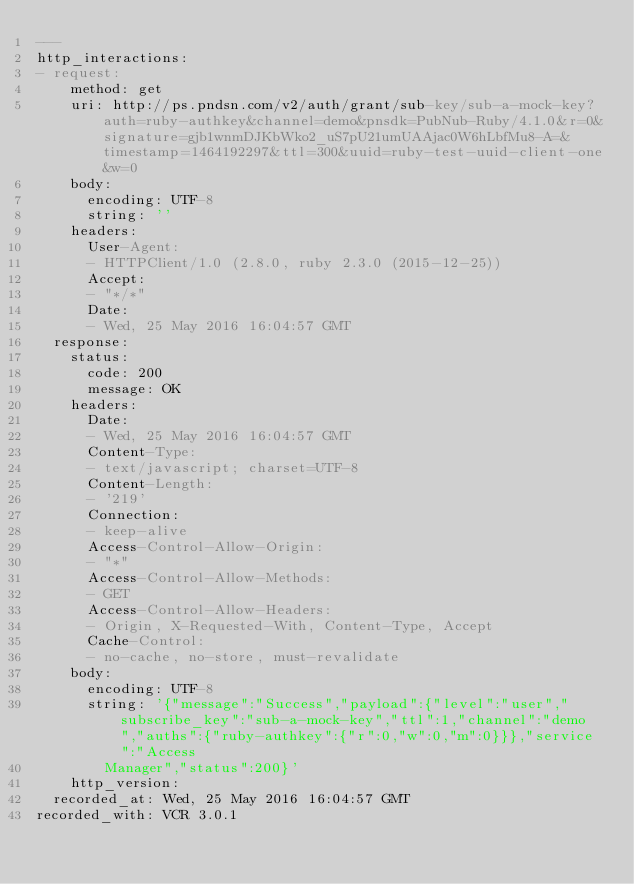<code> <loc_0><loc_0><loc_500><loc_500><_YAML_>---
http_interactions:
- request:
    method: get
    uri: http://ps.pndsn.com/v2/auth/grant/sub-key/sub-a-mock-key?auth=ruby-authkey&channel=demo&pnsdk=PubNub-Ruby/4.1.0&r=0&signature=gjb1wnmDJKbWko2_uS7pU21umUAAjac0W6hLbfMu8-A=&timestamp=1464192297&ttl=300&uuid=ruby-test-uuid-client-one&w=0
    body:
      encoding: UTF-8
      string: ''
    headers:
      User-Agent:
      - HTTPClient/1.0 (2.8.0, ruby 2.3.0 (2015-12-25))
      Accept:
      - "*/*"
      Date:
      - Wed, 25 May 2016 16:04:57 GMT
  response:
    status:
      code: 200
      message: OK
    headers:
      Date:
      - Wed, 25 May 2016 16:04:57 GMT
      Content-Type:
      - text/javascript; charset=UTF-8
      Content-Length:
      - '219'
      Connection:
      - keep-alive
      Access-Control-Allow-Origin:
      - "*"
      Access-Control-Allow-Methods:
      - GET
      Access-Control-Allow-Headers:
      - Origin, X-Requested-With, Content-Type, Accept
      Cache-Control:
      - no-cache, no-store, must-revalidate
    body:
      encoding: UTF-8
      string: '{"message":"Success","payload":{"level":"user","subscribe_key":"sub-a-mock-key","ttl":1,"channel":"demo","auths":{"ruby-authkey":{"r":0,"w":0,"m":0}}},"service":"Access
        Manager","status":200}'
    http_version: 
  recorded_at: Wed, 25 May 2016 16:04:57 GMT
recorded_with: VCR 3.0.1
</code> 